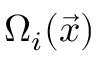Convert formula to latex. <formula><loc_0><loc_0><loc_500><loc_500>\Omega _ { i } ( \vec { x } )</formula> 